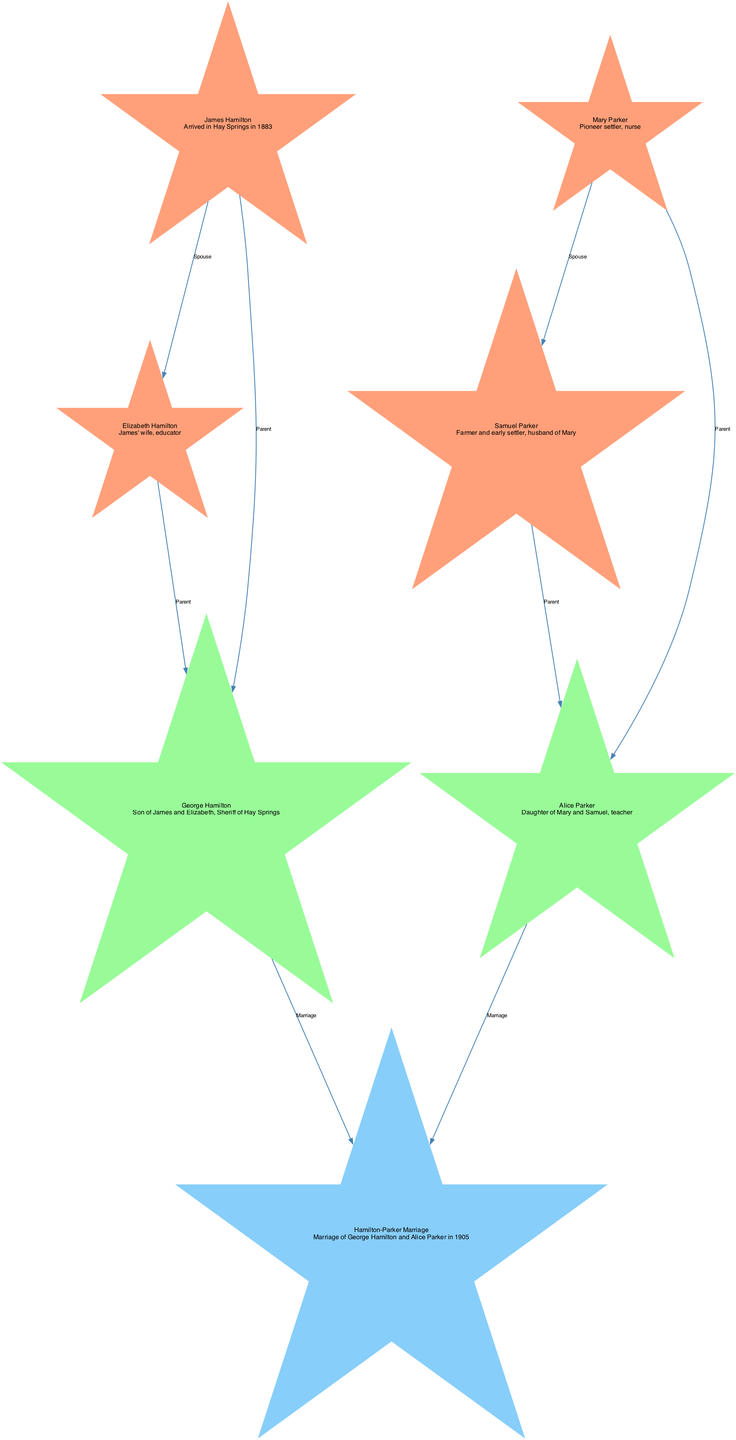What is the relationship between James Hamilton and Elizabeth Hamilton? The edge connecting James Hamilton (ID 1) to Elizabeth Hamilton (ID 2) is labeled "Spouse," indicating they are married.
Answer: Spouse Who is the child of James and Elizabeth Hamilton? The diagram shows an edge leading from James Hamilton (ID 1) and Elizabeth Hamilton (ID 2) to George Hamilton (ID 3), labeled "Parent." This means George is their child.
Answer: George Hamilton How many ancestor nodes are in the diagram? The nodes labeled as "ancestor" are James Hamilton (ID 1), Elizabeth Hamilton (ID 2), Mary Parker (ID 4), and Samuel Parker (ID 5). Counting these gives us a total of four ancestor nodes.
Answer: 4 What year did George Hamilton and Alice Parker get married? The event connecting George Hamilton (ID 3) and Alice Parker (ID 6) is labeled as "Marriage" and is accompanied by the details stating they married in 1905.
Answer: 1905 Which ancestor is noted as a nurse? In the diagram, Mary Parker (ID 4) is described in the details as a "Pioneer settler, nurse."
Answer: Mary Parker Who are the parents of Alice Parker? The diagram shows edges from both Mary Parker (ID 4) and Samuel Parker (ID 5) leading to Alice Parker (ID 6) labeled "Parent," indicating they are her parents.
Answer: Mary Parker and Samuel Parker What is the label of the event connecting George Hamilton and Alice Parker? The diagram labels the edge between George Hamilton (ID 3) and Alice Parker (ID 6) as "Marriage," indicating the nature of their relationship.
Answer: Marriage How many total edges are shown in the diagram? By counting the edges listed in the diagram (connections, relationships), there are eight edges in total.
Answer: 8 Which descendant is a teacher? Alice Parker (ID 6) is described in the details of the node as a "Daughter of Mary and Samuel, teacher," indicating her profession.
Answer: Alice Parker 